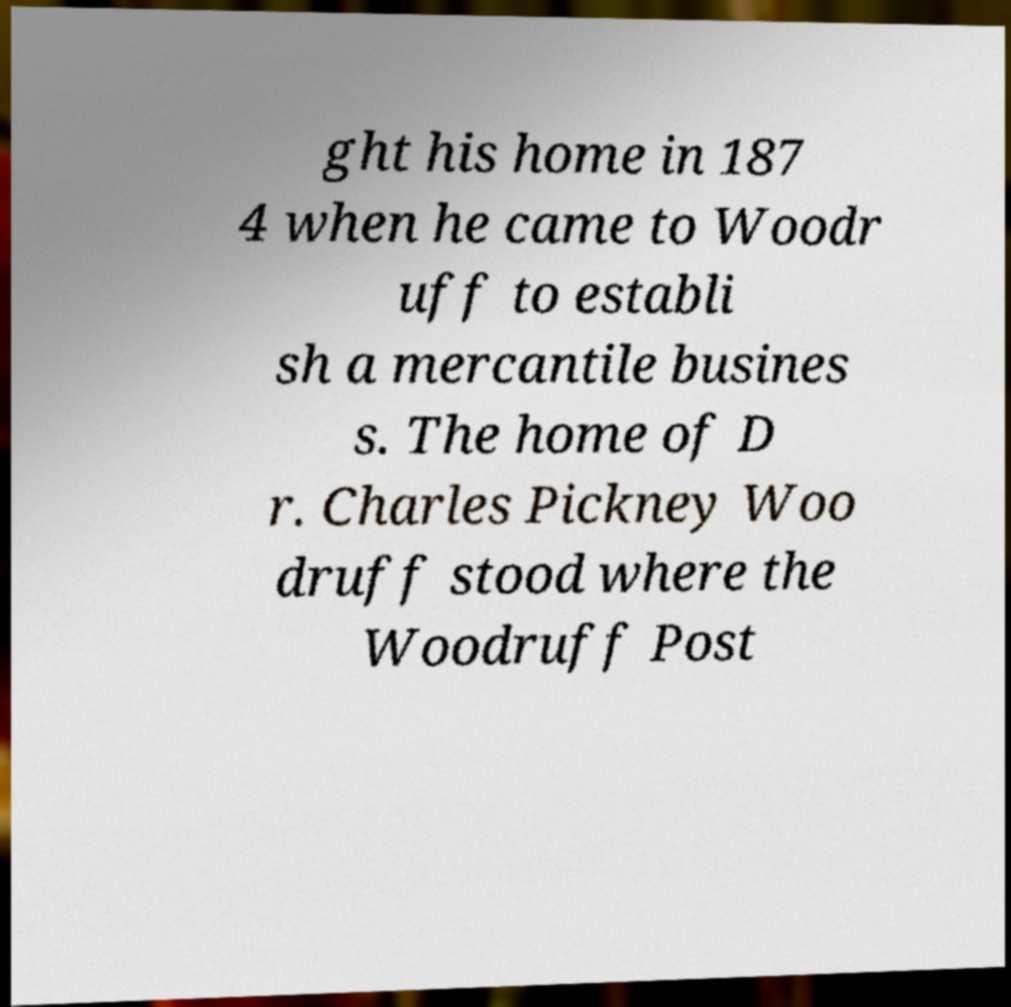For documentation purposes, I need the text within this image transcribed. Could you provide that? ght his home in 187 4 when he came to Woodr uff to establi sh a mercantile busines s. The home of D r. Charles Pickney Woo druff stood where the Woodruff Post 